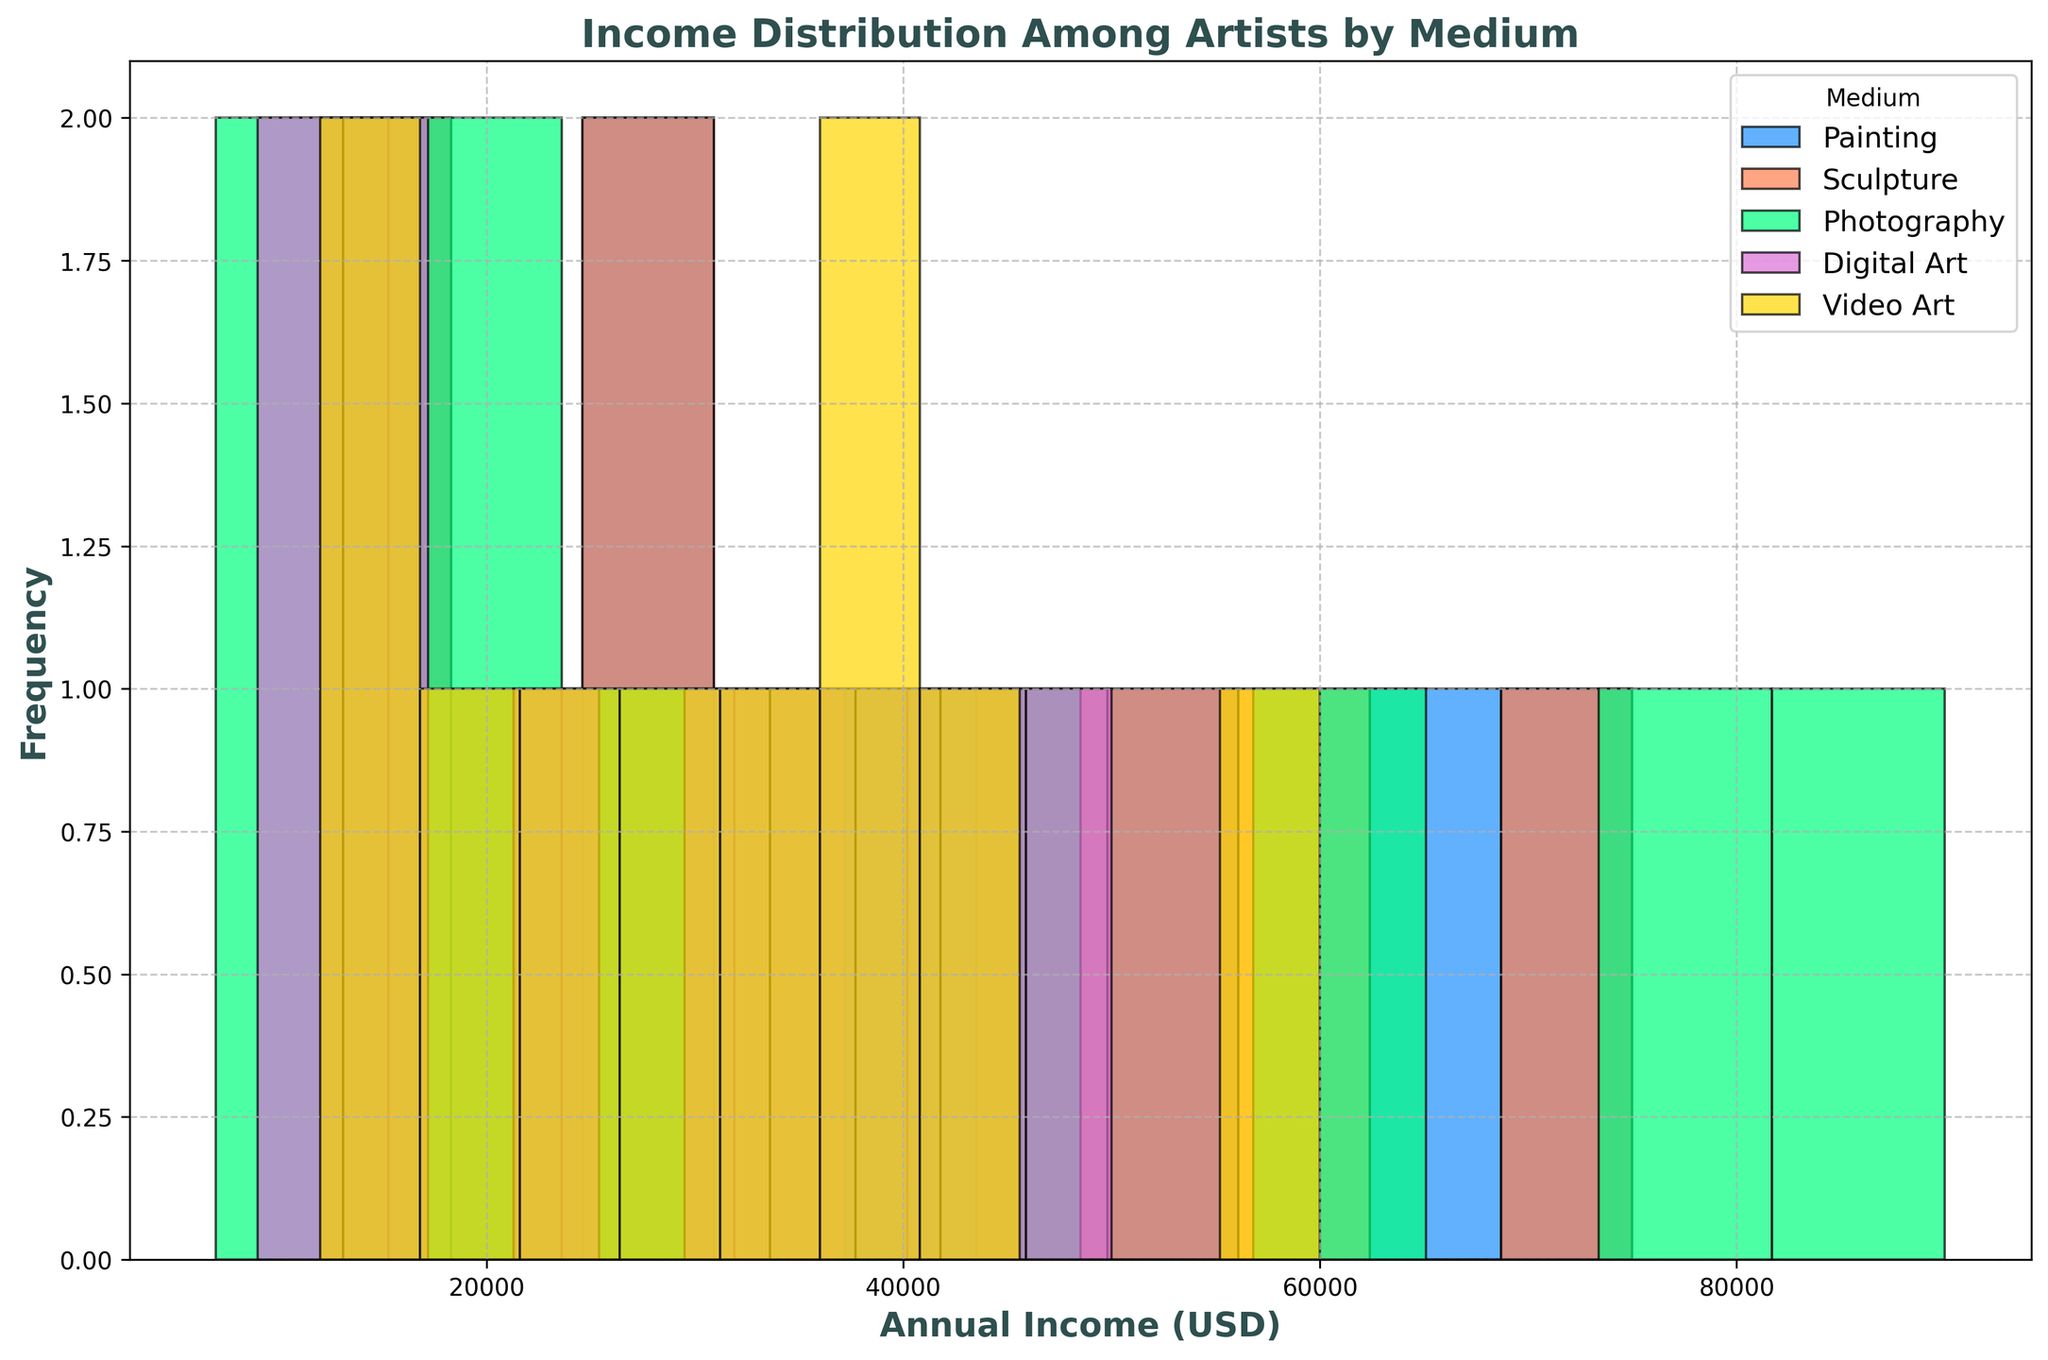What is the most frequent income range for artists working in photography? By looking at the height of the bars corresponding to photography, we can see which income range has the highest frequency.
Answer: The $30,000-$35,000 range has the highest frequency Which medium has the highest frequency of artists earning between $40,000 and $45,000? Observe the bars for each medium in the income range of $40,000 to $45,000 and identify the tallest bar.
Answer: Painting has the highest frequency in this range What is the difference in the number of artists earning between $60,000 to $70,000 for Sculpture and Painting? Count the bars for each medium within the $60,000 to $70,000 range and compute the difference.
Answer: Sculpture has 2 artists, and Painting has 1 artist, so the difference is 1 How does the distribution of income for Digital Art compare to Video Art? Compare the shapes and heights of the histograms for Digital Art and Video Art across different income ranges.
Answer: Digital Art has more artists in the lower income ranges ($10,000 - $15,000) while Video Art is more evenly spread out What is the average income of painters based on the histogram? Identify the midpoints of each income bin for Painting, multiply by the frequency, sum them up and divide by the total number of painters (10).
Answer: Approximately $37,000 How many artists earn more than $50,000 in Photography? Count the bars for Photography that represent income ranges above $50,000.
Answer: 3 artists earn more than $50,000 Which medium has the widest range of incomes? Examine the span of the income ranges for each medium, from the lowest to the highest.
Answer: Photography, ranging from $7,000 to $90,000 What is the median income for Video Art based on the histogram? Identify the middle value in the ordered list of incomes for Video Art.
Answer: Approximately $34,000 For Sculpture, which income range shows the least number of artists? Identify the income range with the smallest bar for Sculpture.
Answer: $12,000-$15,000 What is the proportion of Digital Art artists earning between $20,000 and $40,000? Count the number of artists in the specified range and divide by the total number of Digital Art artists (10).
Answer: 3 out of 10 artists, so 30% 